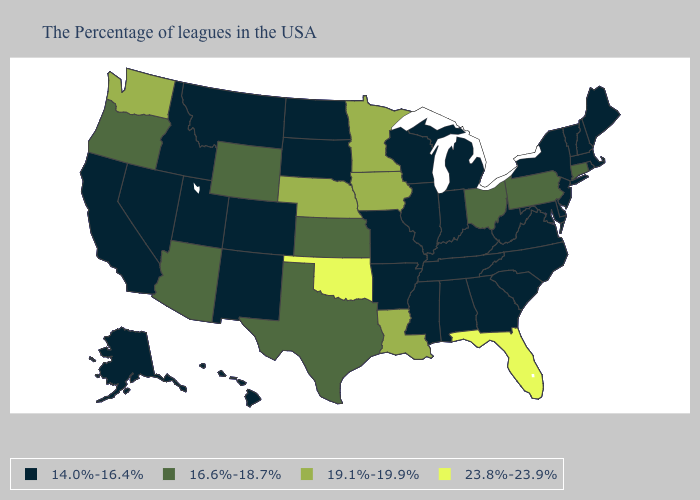Name the states that have a value in the range 23.8%-23.9%?
Be succinct. Florida, Oklahoma. Among the states that border Colorado , does Utah have the lowest value?
Answer briefly. Yes. Does North Carolina have a lower value than Texas?
Write a very short answer. Yes. Name the states that have a value in the range 23.8%-23.9%?
Keep it brief. Florida, Oklahoma. Name the states that have a value in the range 14.0%-16.4%?
Keep it brief. Maine, Massachusetts, Rhode Island, New Hampshire, Vermont, New York, New Jersey, Delaware, Maryland, Virginia, North Carolina, South Carolina, West Virginia, Georgia, Michigan, Kentucky, Indiana, Alabama, Tennessee, Wisconsin, Illinois, Mississippi, Missouri, Arkansas, South Dakota, North Dakota, Colorado, New Mexico, Utah, Montana, Idaho, Nevada, California, Alaska, Hawaii. What is the highest value in the USA?
Quick response, please. 23.8%-23.9%. Name the states that have a value in the range 23.8%-23.9%?
Be succinct. Florida, Oklahoma. What is the value of Rhode Island?
Answer briefly. 14.0%-16.4%. Name the states that have a value in the range 23.8%-23.9%?
Keep it brief. Florida, Oklahoma. Does Washington have a lower value than Alaska?
Concise answer only. No. Which states have the lowest value in the USA?
Write a very short answer. Maine, Massachusetts, Rhode Island, New Hampshire, Vermont, New York, New Jersey, Delaware, Maryland, Virginia, North Carolina, South Carolina, West Virginia, Georgia, Michigan, Kentucky, Indiana, Alabama, Tennessee, Wisconsin, Illinois, Mississippi, Missouri, Arkansas, South Dakota, North Dakota, Colorado, New Mexico, Utah, Montana, Idaho, Nevada, California, Alaska, Hawaii. Name the states that have a value in the range 23.8%-23.9%?
Quick response, please. Florida, Oklahoma. Which states have the lowest value in the West?
Answer briefly. Colorado, New Mexico, Utah, Montana, Idaho, Nevada, California, Alaska, Hawaii. Which states have the lowest value in the Northeast?
Concise answer only. Maine, Massachusetts, Rhode Island, New Hampshire, Vermont, New York, New Jersey. Name the states that have a value in the range 23.8%-23.9%?
Quick response, please. Florida, Oklahoma. 